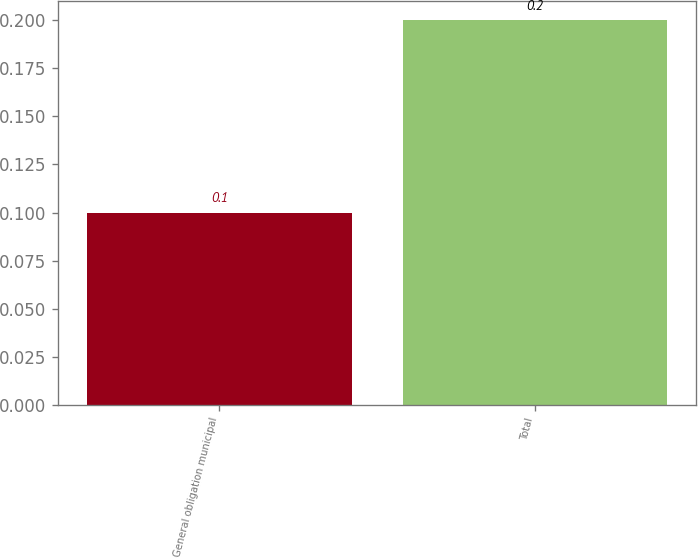Convert chart. <chart><loc_0><loc_0><loc_500><loc_500><bar_chart><fcel>General obligation municipal<fcel>Total<nl><fcel>0.1<fcel>0.2<nl></chart> 